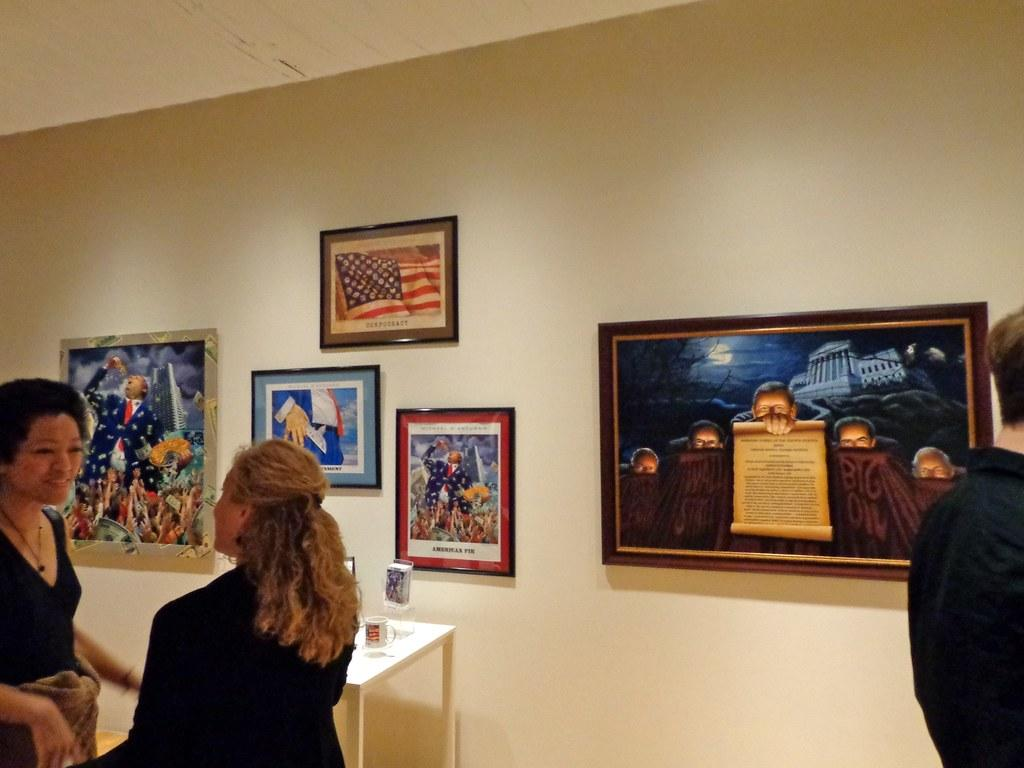How many people are in the foreground of the image? There are three persons standing in the foreground of the image. Where was the image taken? The image was taken in a hall. What can be seen in the background of the image? There is a table and wall paintings in the background of the image. What type of lettuce is being used in the operation depicted in the image? There is no operation or lettuce present in the image. Can you describe the beetle that is crawling on the table in the background of the image? There is no beetle present on the table or in the image. 